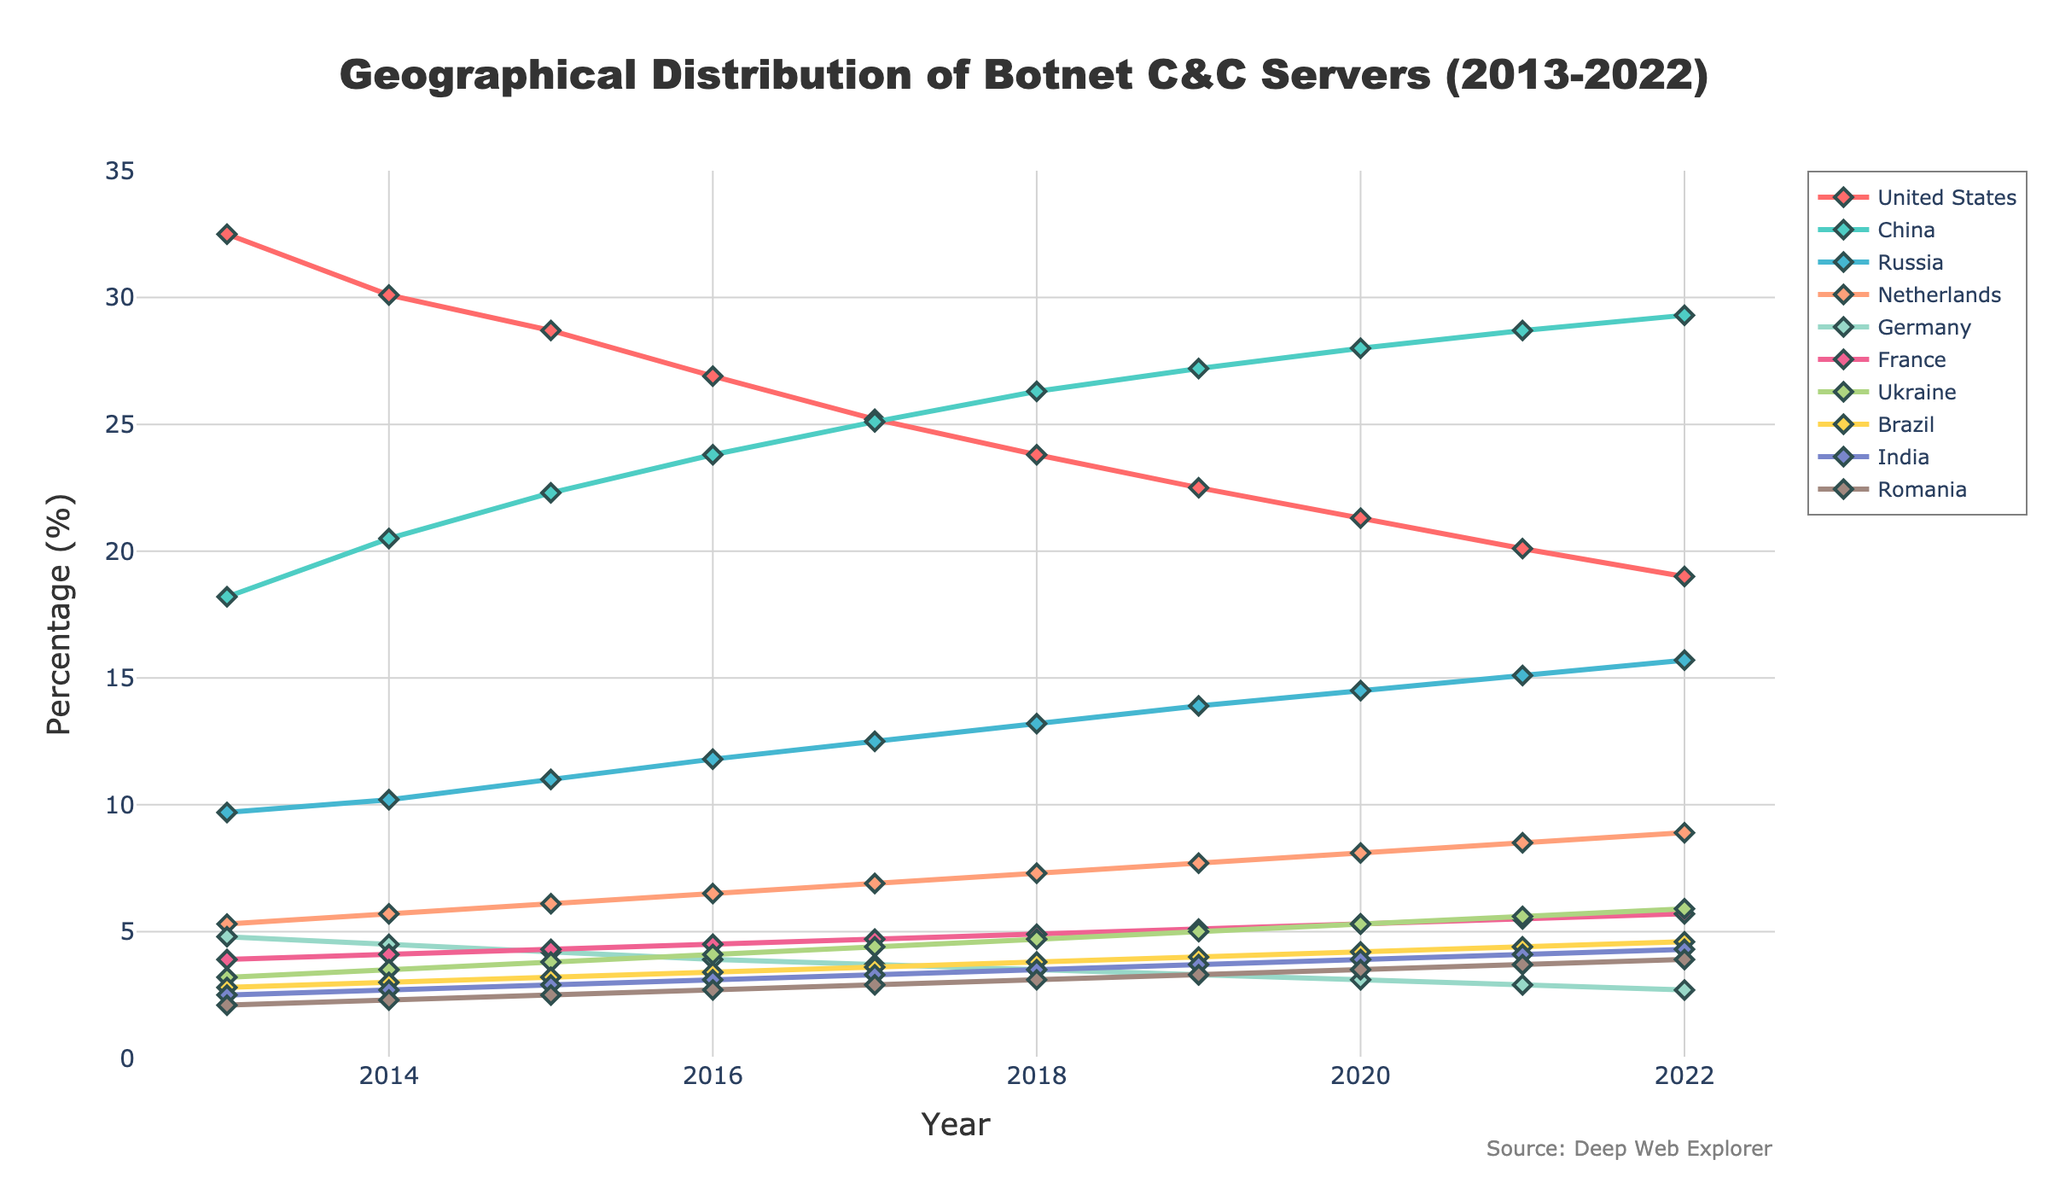What country had the highest percentage of botnet C&C servers in 2022? From the figure, the top country in 2022 can be found by looking at the highest line value in the last year on the x-axis. China has the highest percentage, shown at around 29.3%.
Answer: China Which two countries showed a consistent increase in botnet C&C server percentages from 2013 to 2022? To find this, examine each country's line over the years to see which ones steadily increase. China and Russia are the ones with increasing trends from 2013 to 2022.
Answer: China and Russia By how much did the United States' percentage of botnet C&C servers decrease from 2013 to 2022? Subtract the 2022 percentage of the United States (19.0) from the 2013 percentage (32.5): 32.5 - 19.0 = 13.5.
Answer: 13.5 Which country had the second highest percentage of botnet C&C servers in 2016, and what was the percentage? To answer this, look at the 2016 data points and identify the second highest line value, which is for China at approximately 23.8%.
Answer: China, 23.8% How many countries had a percentage decrease in botnet C&C servers from 2015 to 2018? Compare the percentage values of each country from 2015 to 2018: United States (28.7 to 23.8), Netherlands (6.1 to 7.3), Germany (4.2 to 3.5), France (4.3 to 4.9), Ukraine (3.8 to 4.7), Brazil (3.2 to 3.8), India (2.9 to 3.5), Romania (2.5 to 3.1). Out of these, only the United States and Germany had a decrease.
Answer: 2 What is the difference in percentage of botnet C&C servers between Russia and the Netherlands in 2020? Find the 2020 percentages for Russia (14.5) and the Netherlands (8.1), then subtract: 14.5 - 8.1 = 6.4.
Answer: 6.4 Which country's percentage of botnet C&C servers stayed below 5% from 2013 to 2022? Checking each country's line, both Germany and Romania's percentages stayed below 5% throughout the decade.
Answer: Germany and Romania Looking at visual trends, which country showed a significant color-coded line increase around 2016? Refer to the colored lines around 2016 to see sudden rises, and the green line representing China shows a significant rise starting around that year.
Answer: China What's the total percentage increase of botnet C&C servers for Ukraine from 2013 to 2022? Subtract the 2013 percentage (3.2) from the 2022 percentage (5.9): 5.9 - 3.2 = 2.7.
Answer: 2.7 Between which two years did Brazil have the smallest change in percentage of botnet C&C servers? Compare year-to-year changes for Brazil: between 2021 and 2022, the percentage changed from 4.4 to 4.6, which is the smallest difference of 0.2%.
Answer: 2021 and 2022 